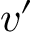<formula> <loc_0><loc_0><loc_500><loc_500>v ^ { \prime }</formula> 